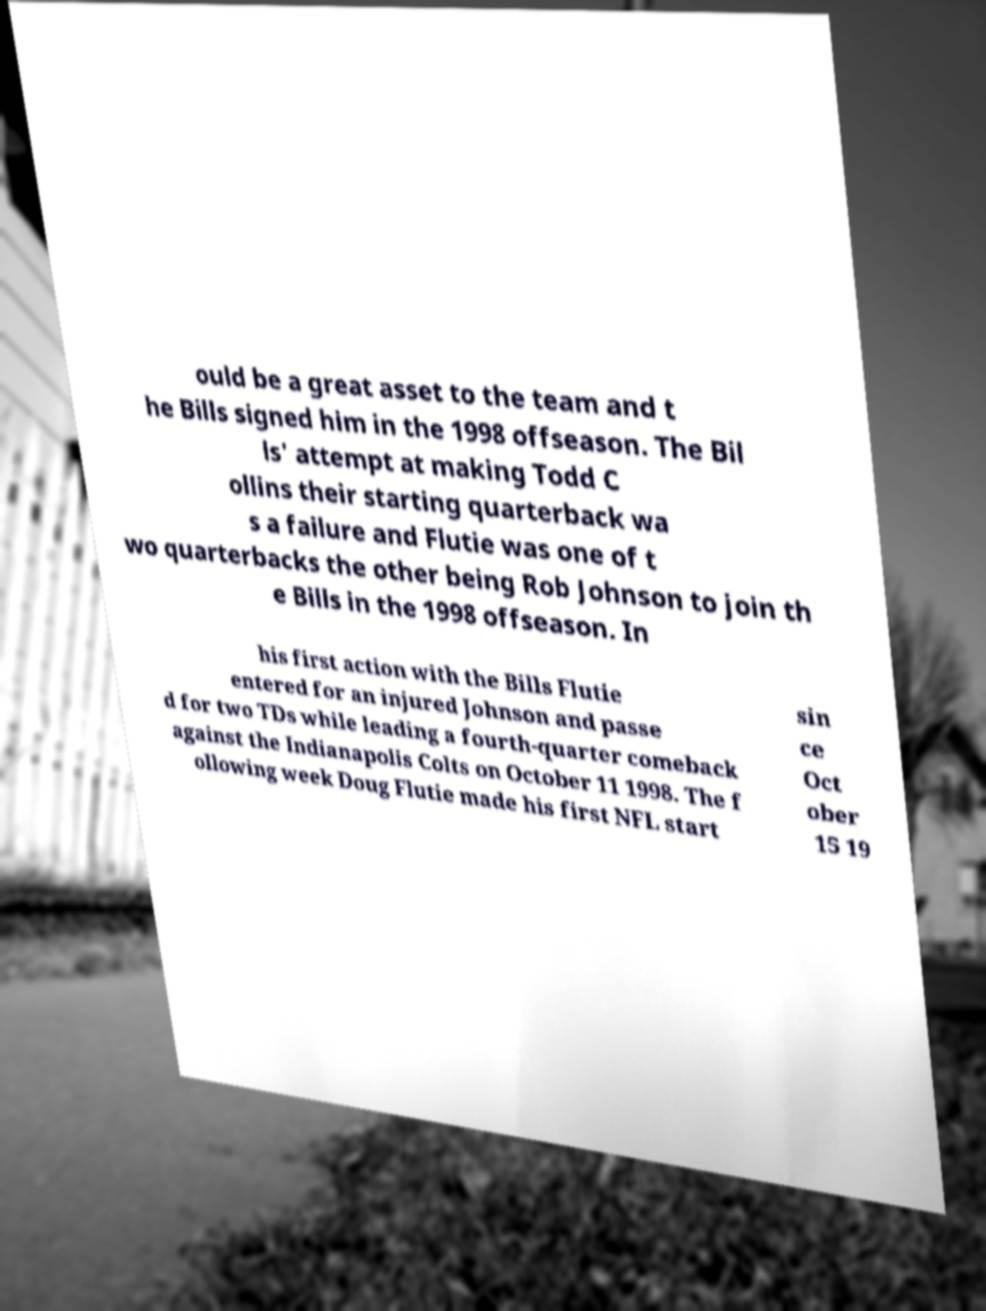Please identify and transcribe the text found in this image. ould be a great asset to the team and t he Bills signed him in the 1998 offseason. The Bil ls' attempt at making Todd C ollins their starting quarterback wa s a failure and Flutie was one of t wo quarterbacks the other being Rob Johnson to join th e Bills in the 1998 offseason. In his first action with the Bills Flutie entered for an injured Johnson and passe d for two TDs while leading a fourth-quarter comeback against the Indianapolis Colts on October 11 1998. The f ollowing week Doug Flutie made his first NFL start sin ce Oct ober 15 19 